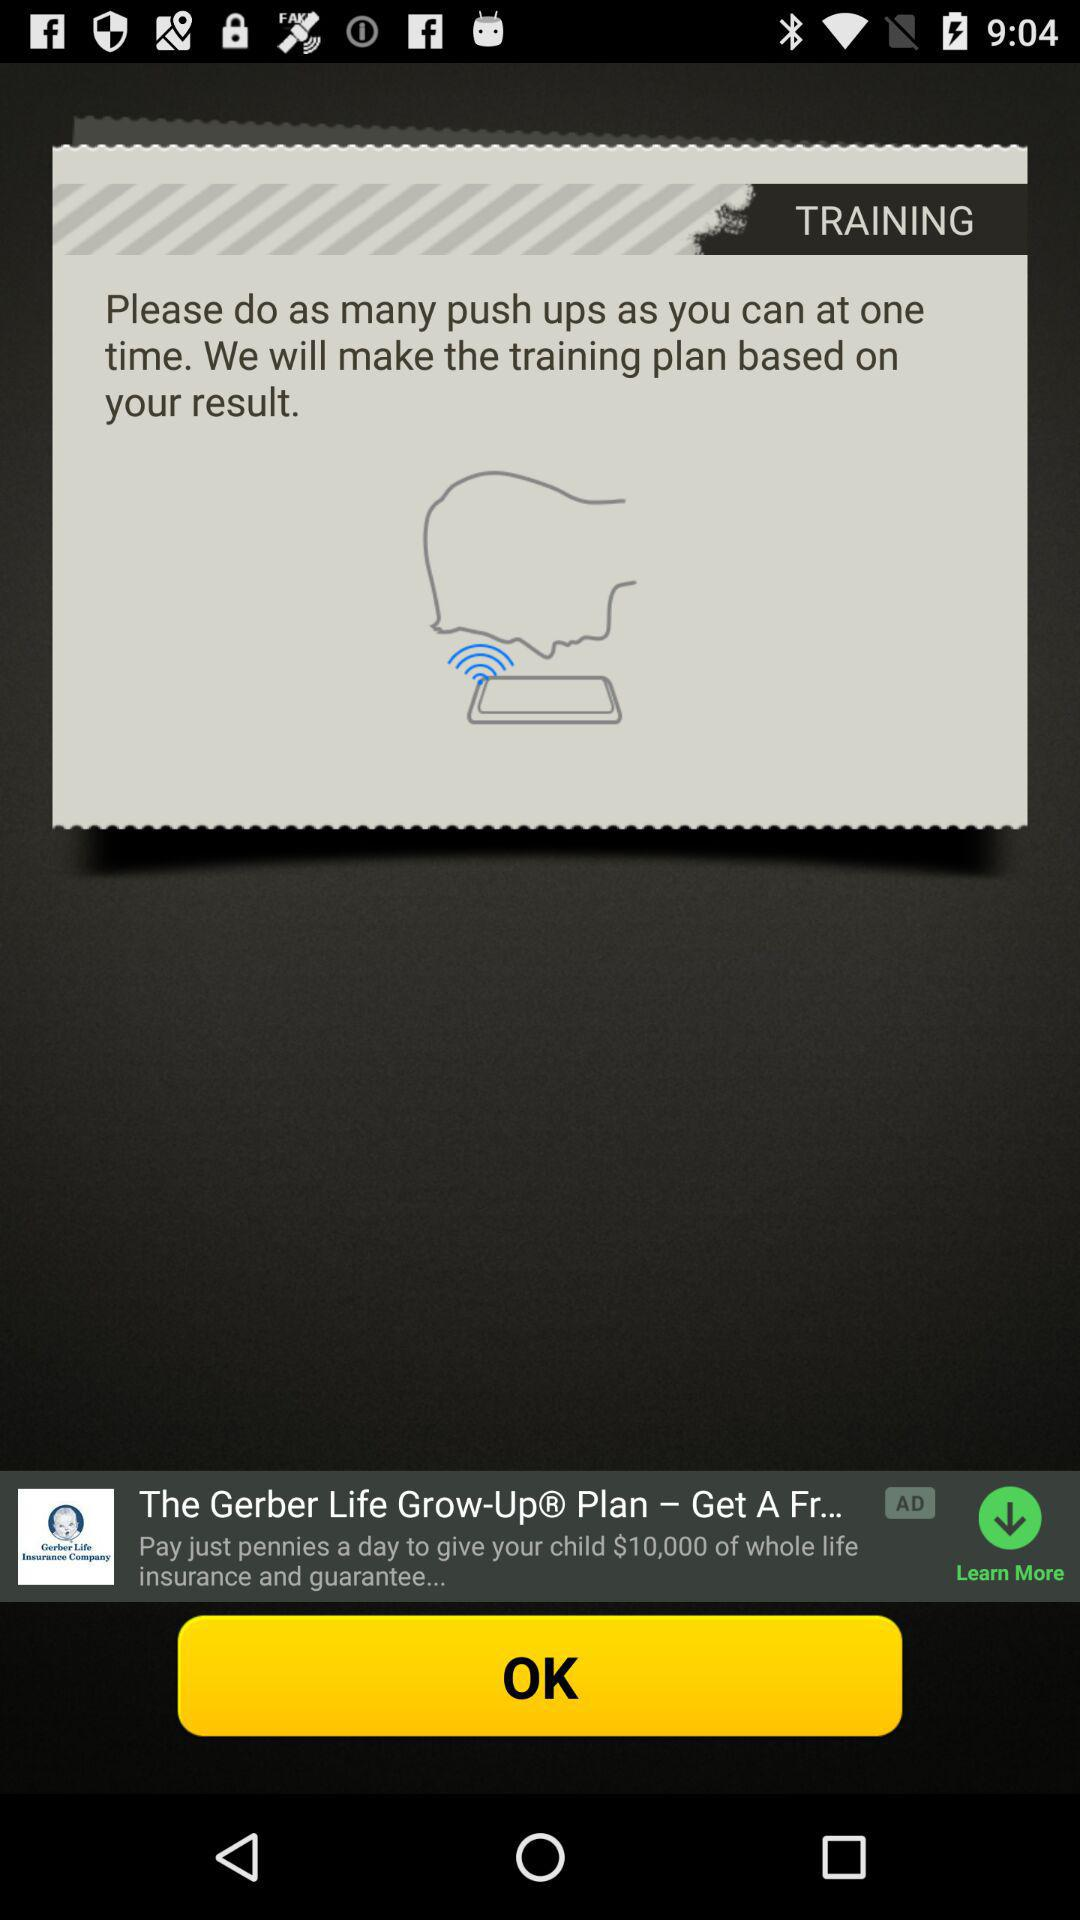What exercise is asked to do? You have to do push ups. 